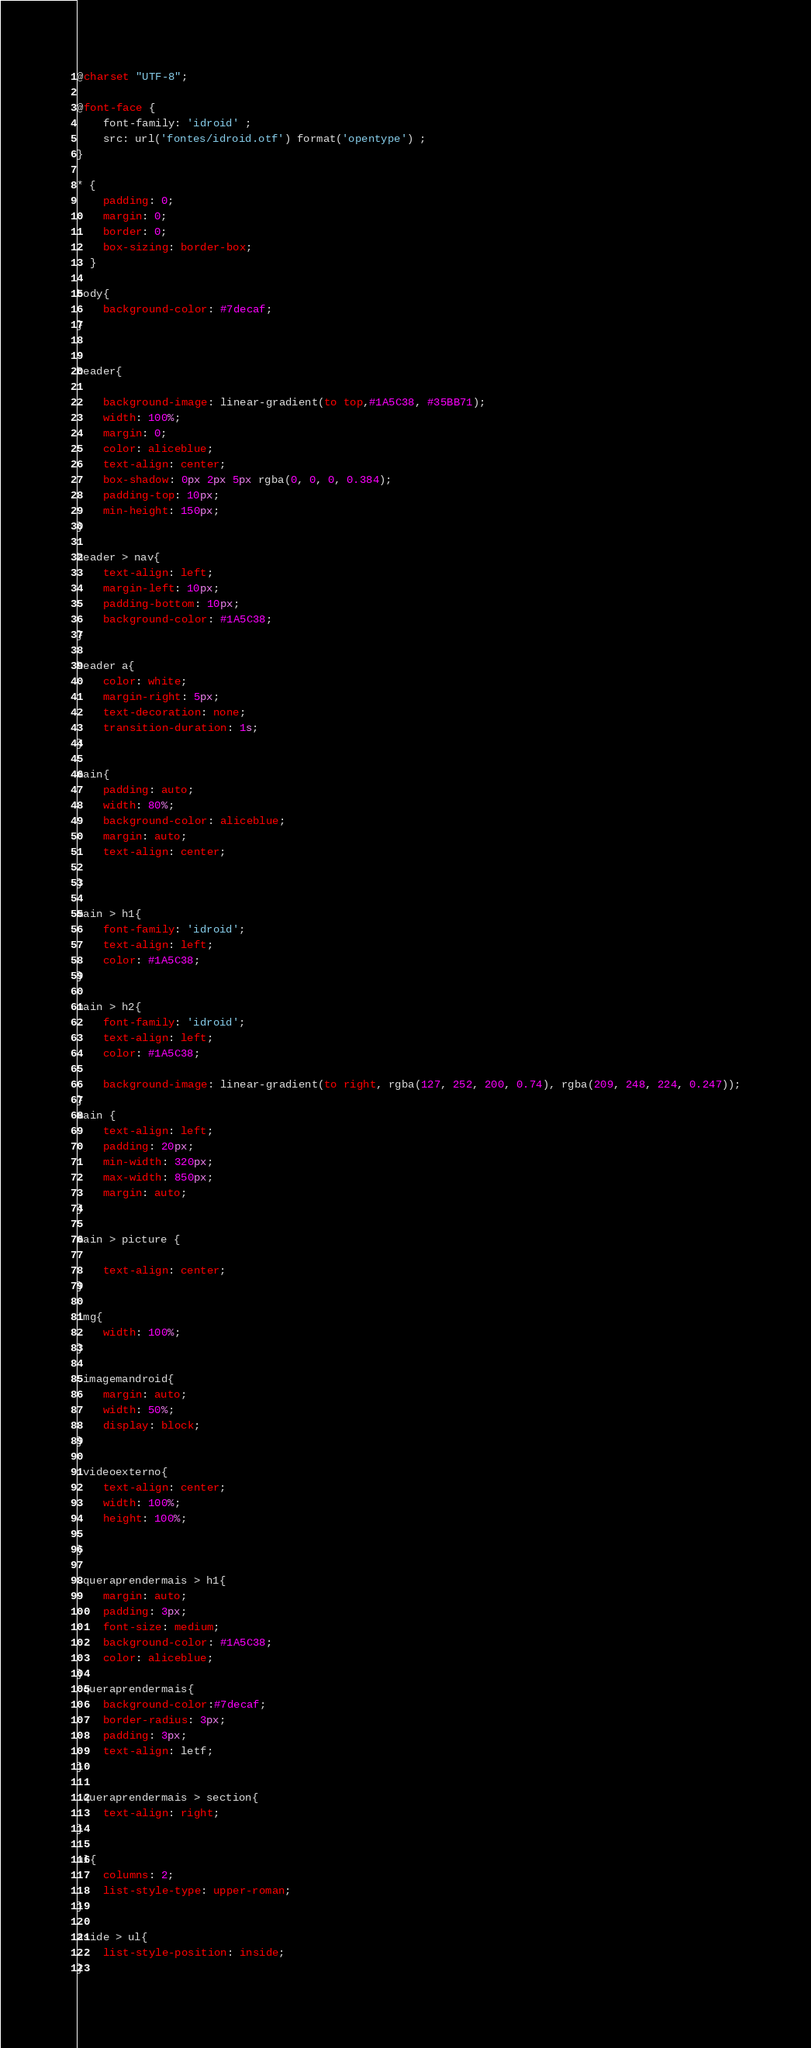Convert code to text. <code><loc_0><loc_0><loc_500><loc_500><_CSS_>@charset "UTF-8";

@font-face {
    font-family: 'idroid' ;
    src: url('fontes/idroid.otf') format('opentype') ;
}

* {
    padding: 0;
    margin: 0;
    border: 0;
    box-sizing: border-box;
  }

body{
    background-color: #7decaf;
}


header{

    background-image: linear-gradient(to top,#1A5C38, #35BB71);
    width: 100%;
    margin: 0;
    color: aliceblue;
    text-align: center;
    box-shadow: 0px 2px 5px rgba(0, 0, 0, 0.384);
    padding-top: 10px;
    min-height: 150px;
}

header > nav{
    text-align: left;
    margin-left: 10px;
    padding-bottom: 10px;
    background-color: #1A5C38;
}

header a{
    color: white;
    margin-right: 5px;    
    text-decoration: none;
    transition-duration: 1s;
}

main{
    padding: auto;
    width: 80%;
    background-color: aliceblue;
    margin: auto;
    text-align: center;

}

main > h1{
    font-family: 'idroid';
    text-align: left;
    color: #1A5C38;
}

main > h2{
    font-family: 'idroid';
    text-align: left;
    color: #1A5C38;
    
    background-image: linear-gradient(to right, rgba(127, 252, 200, 0.74), rgba(209, 248, 224, 0.247));
}
main {
    text-align: left;
    padding: 20px;
    min-width: 320px;
    max-width: 850px;
    margin: auto;
}

main > picture {

    text-align: center;
}

img{
    width: 100%;
}

.imagemandroid{
    margin: auto;
    width: 50%;
    display: block;
}

.videoexterno{
    text-align: center;
    width: 100%;
    height: 100%;
    
}

.queraprendermais > h1{
    margin: auto;
    padding: 3px;
    font-size: medium;
    background-color: #1A5C38;
    color: aliceblue;
}
.queraprendermais{
    background-color:#7decaf;
    border-radius: 3px;
    padding: 3px;
    text-align: letf;
}

.queraprendermais > section{
    text-align: right;
}

ul{
    columns: 2;
    list-style-type: upper-roman;
}

aside > ul{
    list-style-position: inside;
}</code> 